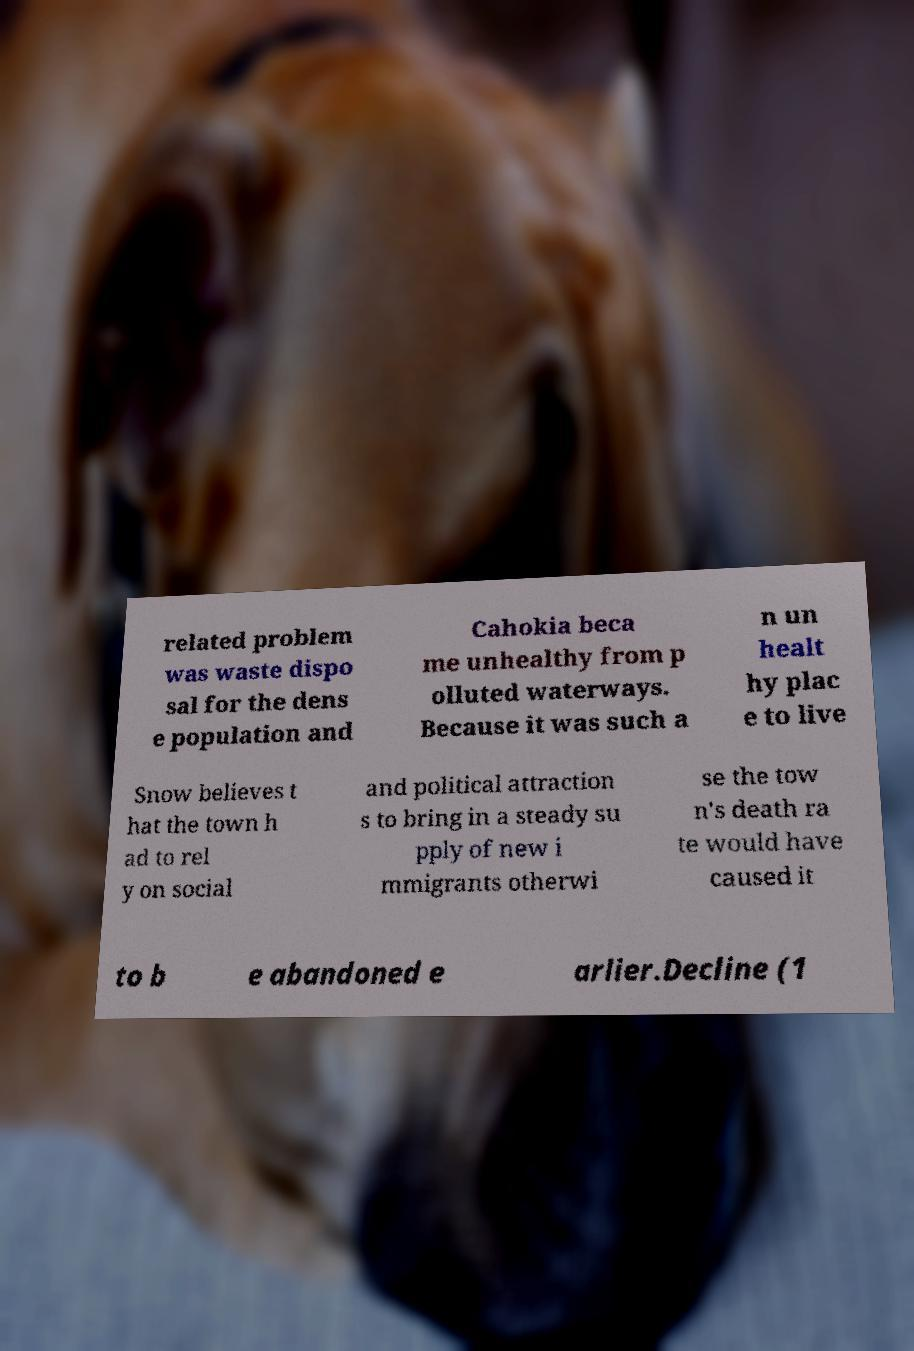There's text embedded in this image that I need extracted. Can you transcribe it verbatim? related problem was waste dispo sal for the dens e population and Cahokia beca me unhealthy from p olluted waterways. Because it was such a n un healt hy plac e to live Snow believes t hat the town h ad to rel y on social and political attraction s to bring in a steady su pply of new i mmigrants otherwi se the tow n's death ra te would have caused it to b e abandoned e arlier.Decline (1 